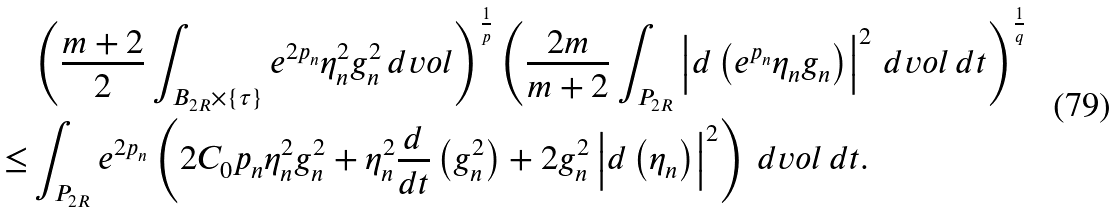<formula> <loc_0><loc_0><loc_500><loc_500>& \left ( \frac { m + 2 } { 2 } \int _ { B _ { 2 R } \times \{ \tau \} } e ^ { 2 p _ { n } } \eta _ { n } ^ { 2 } g _ { n } ^ { 2 } \, d v o l \right ) ^ { \frac { 1 } { p } } \left ( \frac { 2 m } { m + 2 } \int _ { P _ { 2 R } } \left | d \left ( e ^ { p _ { n } } \eta _ { n } g _ { n } \right ) \right | ^ { 2 } \, d v o l \, d t \right ) ^ { \frac { 1 } { q } } \\ \leq & \int _ { P _ { 2 R } } e ^ { 2 p _ { n } } \left ( 2 C _ { 0 } p _ { n } \eta _ { n } ^ { 2 } g _ { n } ^ { 2 } + \eta _ { n } ^ { 2 } \frac { d } { d t } \left ( g _ { n } ^ { 2 } \right ) + 2 g _ { n } ^ { 2 } \left | d \left ( \eta _ { n } \right ) \right | ^ { 2 } \right ) \, d v o l \, d t .</formula> 